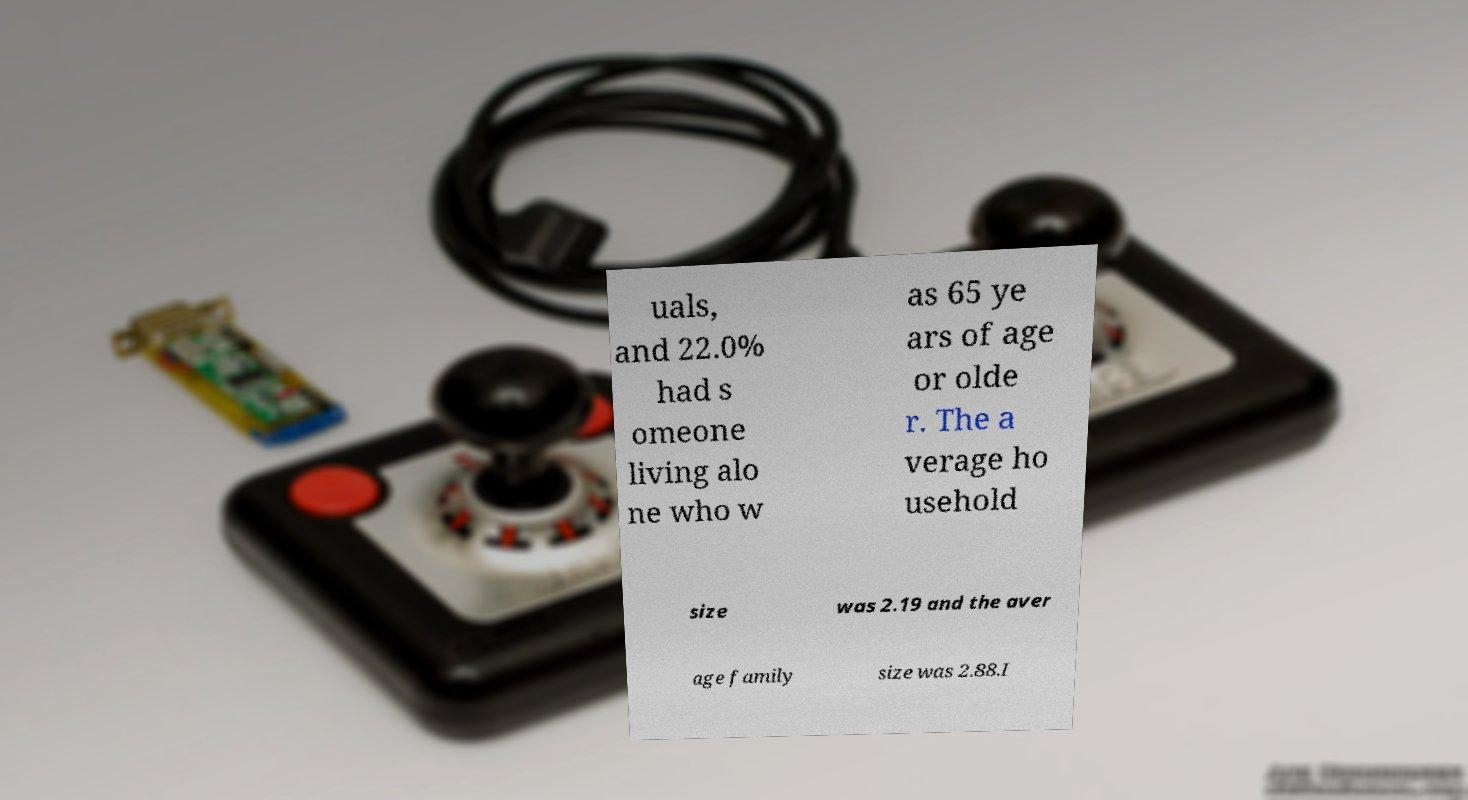I need the written content from this picture converted into text. Can you do that? uals, and 22.0% had s omeone living alo ne who w as 65 ye ars of age or olde r. The a verage ho usehold size was 2.19 and the aver age family size was 2.88.I 